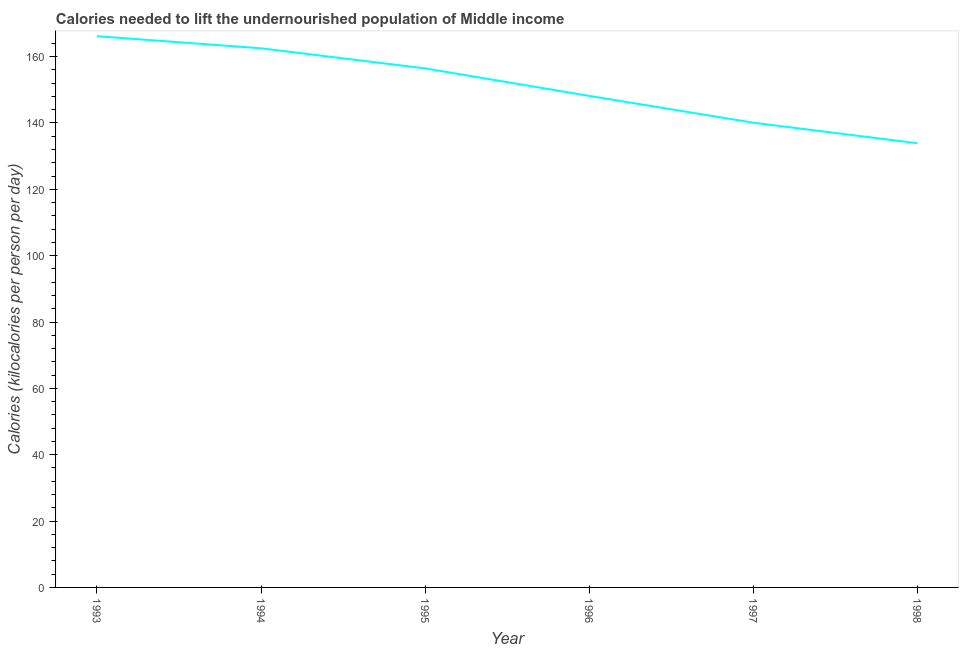What is the depth of food deficit in 1996?
Offer a very short reply. 148.16. Across all years, what is the maximum depth of food deficit?
Make the answer very short. 166.16. Across all years, what is the minimum depth of food deficit?
Make the answer very short. 133.88. In which year was the depth of food deficit maximum?
Your answer should be compact. 1993. What is the sum of the depth of food deficit?
Your answer should be compact. 907.23. What is the difference between the depth of food deficit in 1993 and 1994?
Ensure brevity in your answer.  3.65. What is the average depth of food deficit per year?
Provide a succinct answer. 151.2. What is the median depth of food deficit?
Provide a short and direct response. 152.3. Do a majority of the years between 1994 and 1993 (inclusive) have depth of food deficit greater than 32 kilocalories?
Provide a short and direct response. No. What is the ratio of the depth of food deficit in 1996 to that in 1997?
Provide a succinct answer. 1.06. Is the difference between the depth of food deficit in 1993 and 1997 greater than the difference between any two years?
Your answer should be very brief. No. What is the difference between the highest and the second highest depth of food deficit?
Offer a very short reply. 3.65. Is the sum of the depth of food deficit in 1997 and 1998 greater than the maximum depth of food deficit across all years?
Provide a succinct answer. Yes. What is the difference between the highest and the lowest depth of food deficit?
Your answer should be very brief. 32.28. In how many years, is the depth of food deficit greater than the average depth of food deficit taken over all years?
Your answer should be very brief. 3. Does the depth of food deficit monotonically increase over the years?
Ensure brevity in your answer.  No. How many lines are there?
Offer a very short reply. 1. How many years are there in the graph?
Offer a terse response. 6. Are the values on the major ticks of Y-axis written in scientific E-notation?
Provide a short and direct response. No. Does the graph contain any zero values?
Ensure brevity in your answer.  No. Does the graph contain grids?
Your answer should be compact. No. What is the title of the graph?
Provide a succinct answer. Calories needed to lift the undernourished population of Middle income. What is the label or title of the Y-axis?
Make the answer very short. Calories (kilocalories per person per day). What is the Calories (kilocalories per person per day) in 1993?
Give a very brief answer. 166.16. What is the Calories (kilocalories per person per day) in 1994?
Offer a terse response. 162.51. What is the Calories (kilocalories per person per day) of 1995?
Your answer should be compact. 156.45. What is the Calories (kilocalories per person per day) in 1996?
Give a very brief answer. 148.16. What is the Calories (kilocalories per person per day) in 1997?
Make the answer very short. 140.08. What is the Calories (kilocalories per person per day) of 1998?
Keep it short and to the point. 133.88. What is the difference between the Calories (kilocalories per person per day) in 1993 and 1994?
Ensure brevity in your answer.  3.65. What is the difference between the Calories (kilocalories per person per day) in 1993 and 1995?
Provide a short and direct response. 9.71. What is the difference between the Calories (kilocalories per person per day) in 1993 and 1996?
Ensure brevity in your answer.  18. What is the difference between the Calories (kilocalories per person per day) in 1993 and 1997?
Keep it short and to the point. 26.08. What is the difference between the Calories (kilocalories per person per day) in 1993 and 1998?
Offer a very short reply. 32.28. What is the difference between the Calories (kilocalories per person per day) in 1994 and 1995?
Your answer should be very brief. 6.06. What is the difference between the Calories (kilocalories per person per day) in 1994 and 1996?
Keep it short and to the point. 14.35. What is the difference between the Calories (kilocalories per person per day) in 1994 and 1997?
Offer a terse response. 22.43. What is the difference between the Calories (kilocalories per person per day) in 1994 and 1998?
Keep it short and to the point. 28.62. What is the difference between the Calories (kilocalories per person per day) in 1995 and 1996?
Your answer should be compact. 8.29. What is the difference between the Calories (kilocalories per person per day) in 1995 and 1997?
Your answer should be very brief. 16.37. What is the difference between the Calories (kilocalories per person per day) in 1995 and 1998?
Offer a terse response. 22.57. What is the difference between the Calories (kilocalories per person per day) in 1996 and 1997?
Your response must be concise. 8.08. What is the difference between the Calories (kilocalories per person per day) in 1996 and 1998?
Offer a very short reply. 14.28. What is the difference between the Calories (kilocalories per person per day) in 1997 and 1998?
Your response must be concise. 6.2. What is the ratio of the Calories (kilocalories per person per day) in 1993 to that in 1994?
Your response must be concise. 1.02. What is the ratio of the Calories (kilocalories per person per day) in 1993 to that in 1995?
Make the answer very short. 1.06. What is the ratio of the Calories (kilocalories per person per day) in 1993 to that in 1996?
Offer a terse response. 1.12. What is the ratio of the Calories (kilocalories per person per day) in 1993 to that in 1997?
Offer a terse response. 1.19. What is the ratio of the Calories (kilocalories per person per day) in 1993 to that in 1998?
Provide a short and direct response. 1.24. What is the ratio of the Calories (kilocalories per person per day) in 1994 to that in 1995?
Your answer should be compact. 1.04. What is the ratio of the Calories (kilocalories per person per day) in 1994 to that in 1996?
Provide a short and direct response. 1.1. What is the ratio of the Calories (kilocalories per person per day) in 1994 to that in 1997?
Provide a succinct answer. 1.16. What is the ratio of the Calories (kilocalories per person per day) in 1994 to that in 1998?
Your answer should be compact. 1.21. What is the ratio of the Calories (kilocalories per person per day) in 1995 to that in 1996?
Keep it short and to the point. 1.06. What is the ratio of the Calories (kilocalories per person per day) in 1995 to that in 1997?
Keep it short and to the point. 1.12. What is the ratio of the Calories (kilocalories per person per day) in 1995 to that in 1998?
Provide a succinct answer. 1.17. What is the ratio of the Calories (kilocalories per person per day) in 1996 to that in 1997?
Keep it short and to the point. 1.06. What is the ratio of the Calories (kilocalories per person per day) in 1996 to that in 1998?
Your answer should be compact. 1.11. What is the ratio of the Calories (kilocalories per person per day) in 1997 to that in 1998?
Your answer should be compact. 1.05. 